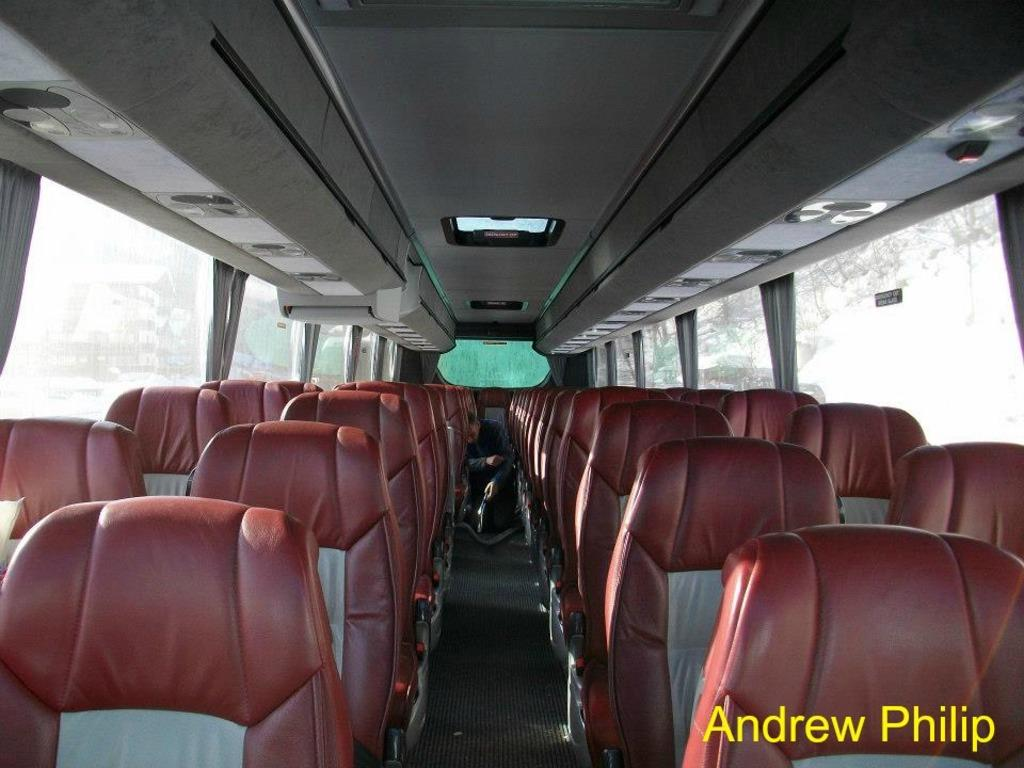What is the setting of the image? The image shows the inside view of a bus. What can be found inside the bus? There are seats in the bus. What can be seen outside the bus through the windows? There are trees visible in the background of the image. Is there any text present in the image? Yes, there is some text at the right bottom of the image. How many dogs are sitting on the seats in the image? There are no dogs present in the image; it shows the inside view of a bus with seats. What is the purpose of the text at the right bottom of the image? The purpose of the text cannot be determined from the image alone, as it may serve various purposes such as informational, promotional, or decorative. 